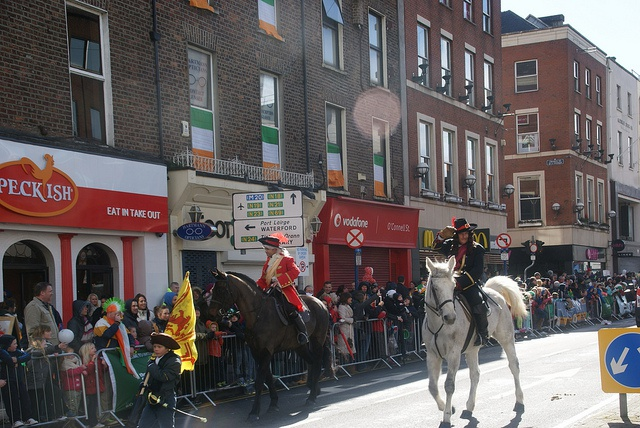Describe the objects in this image and their specific colors. I can see people in black, gray, maroon, and darkgray tones, horse in black, darkgray, gray, and white tones, horse in black, gray, and darkgray tones, people in black, brown, darkgray, and maroon tones, and people in black, maroon, and gray tones in this image. 